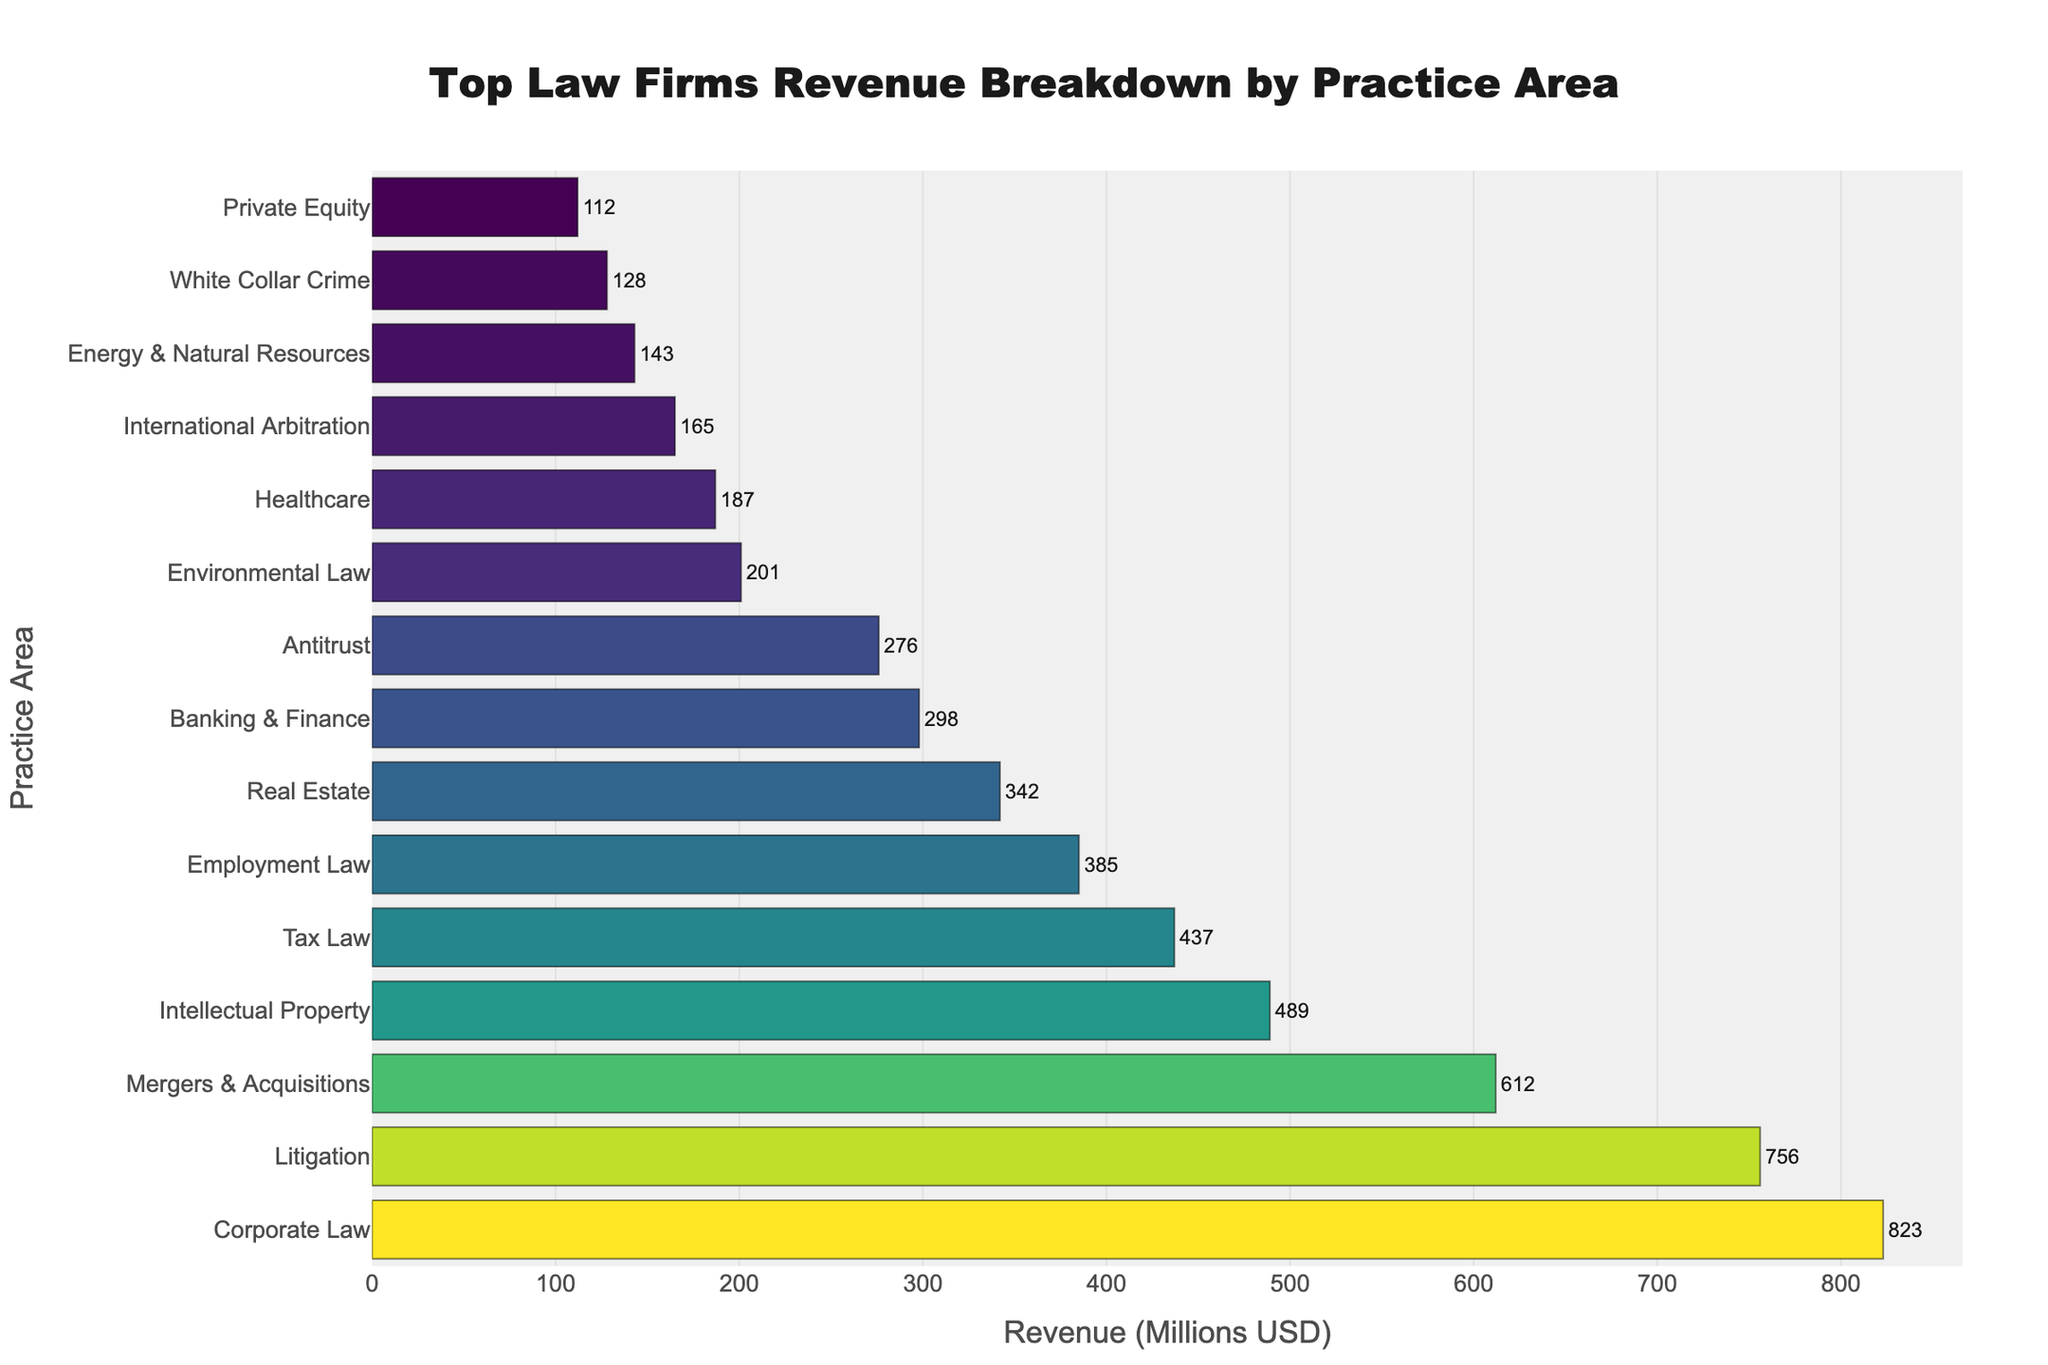What is the practice area with the highest revenue? By observing the lengths of the bars in the chart, we notice that "Corporate Law" has the longest bar. This indicates it has the highest revenue.
Answer: Corporate Law How much more revenue does Corporate Law generate compared to Employment Law? The revenue for Corporate Law is 823 million USD. The revenue for Employment Law is 385 million USD. The difference is calculated as 823 - 385.
Answer: 438 million USD Which practice area has the lowest revenue? By observing the chart, the shortest bar corresponds to "Private Equity," indicating it has the lowest revenue.
Answer: Private Equity What is the total revenue generated by Intellectual Property and Antitrust combined? The revenue for Intellectual Property is 489 million USD and for Antitrust is 276 million USD. Adding these together gives 489 + 276.
Answer: 765 million USD Between Real Estate and Banking & Finance, which practice area generates more revenue and by how much? Real Estate generates 342 million USD and Banking & Finance generates 298 million USD. The difference is calculated as 342 - 298.
Answer: Real Estate by 44 million USD What is the average revenue generated by the top three practice areas? The top three practice areas are Corporate Law (823 million USD), Litigation (756 million USD), and Mergers & Acquisitions (612 million USD). The sum is 823 + 756 + 612 = 2191. The average is 2191 / 3.
Answer: 730.33 million USD Which practice areas generate less than 200 million USD in revenue? By observing the chart, the practice areas with revenue bars less than the 200 million line are Environmental Law, Healthcare, International Arbitration, Energy & Natural Resources, White Collar Crime, and Private Equity.
Answer: Environmental Law, Healthcare, International Arbitration, Energy & Natural Resources, White Collar Crime, Private Equity How does the revenue difference between Mergers & Acquisitions and Tax Law compare to the revenue for Private Equity? The revenue difference between Mergers & Acquisitions (612 million USD) and Tax Law (437 million USD) is 612 - 437 = 175 million USD. Private Equity generates 112 million USD, and 175 million USD is greater than 112 million USD.
Answer: 175 million USD is greater than Private Equity's revenue Is the revenue from Healthcare greater than that from Energy & Natural Resources? By comparing the bars for these two practice areas, Healthcare generates 187 million USD and Energy & Natural Resources generates 143 million USD. Since 187 is greater than 143, the revenue from Healthcare is indeed greater.
Answer: Yes 